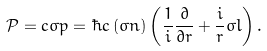Convert formula to latex. <formula><loc_0><loc_0><loc_500><loc_500>\mathcal { P } = c \sigma p = \hbar { c } \left ( \sigma n \right ) \left ( \frac { 1 } { i } \frac { \partial } { \partial r } + \frac { i } { r } \sigma l \right ) .</formula> 